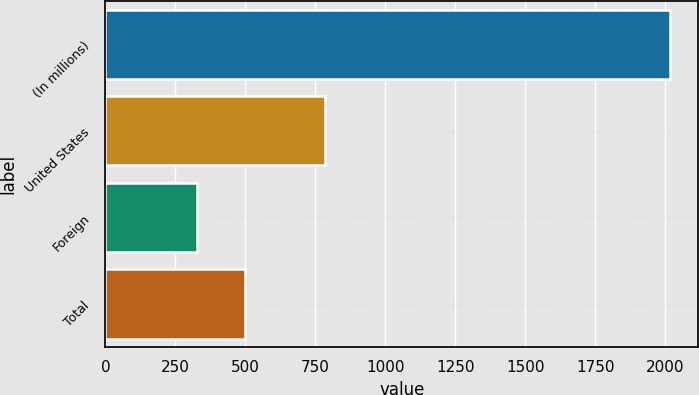Convert chart to OTSL. <chart><loc_0><loc_0><loc_500><loc_500><bar_chart><fcel>(In millions)<fcel>United States<fcel>Foreign<fcel>Total<nl><fcel>2017<fcel>783<fcel>329<fcel>497.8<nl></chart> 